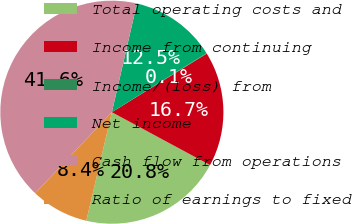<chart> <loc_0><loc_0><loc_500><loc_500><pie_chart><fcel>Total operating costs and<fcel>Income from continuing<fcel>Income/(loss) from<fcel>Net income<fcel>Cash flow from operations<fcel>Ratio of earnings to fixed<nl><fcel>20.82%<fcel>16.67%<fcel>0.07%<fcel>12.52%<fcel>41.56%<fcel>8.37%<nl></chart> 